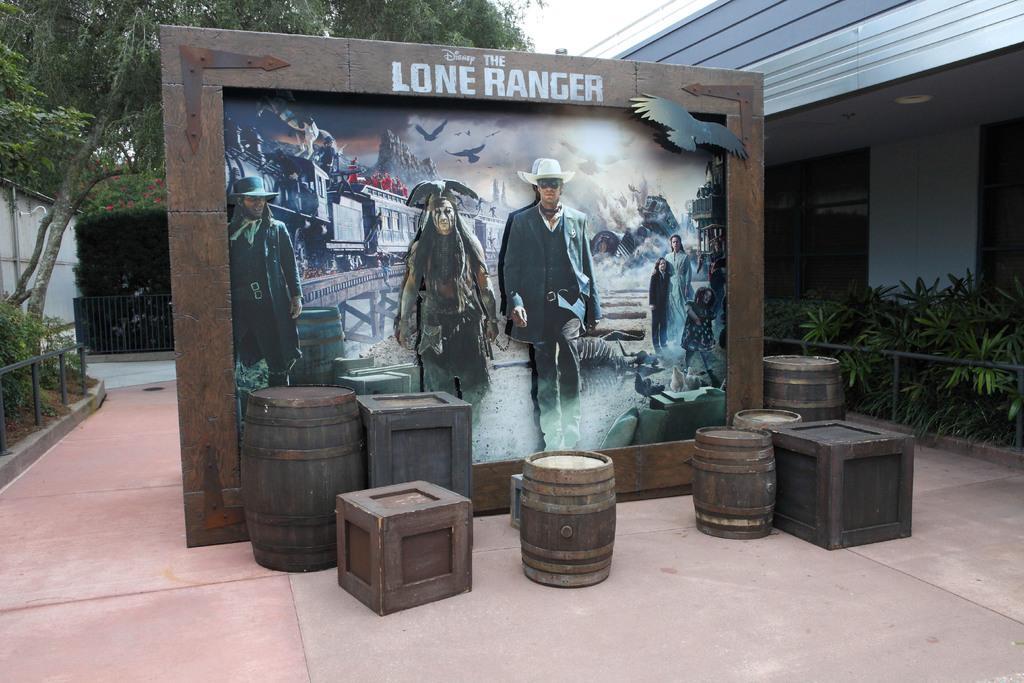Please provide a concise description of this image. In this picture we can see a few barrels, boxes and a wooden frame on the path. In this frame, we can see a few people, a barrel, animals, buildings, birds in the sky and other objects. We can see some plants and some fencing on the right and left side of the image. There is a building on the right We can see a fence, flowers and some trees in the background. 